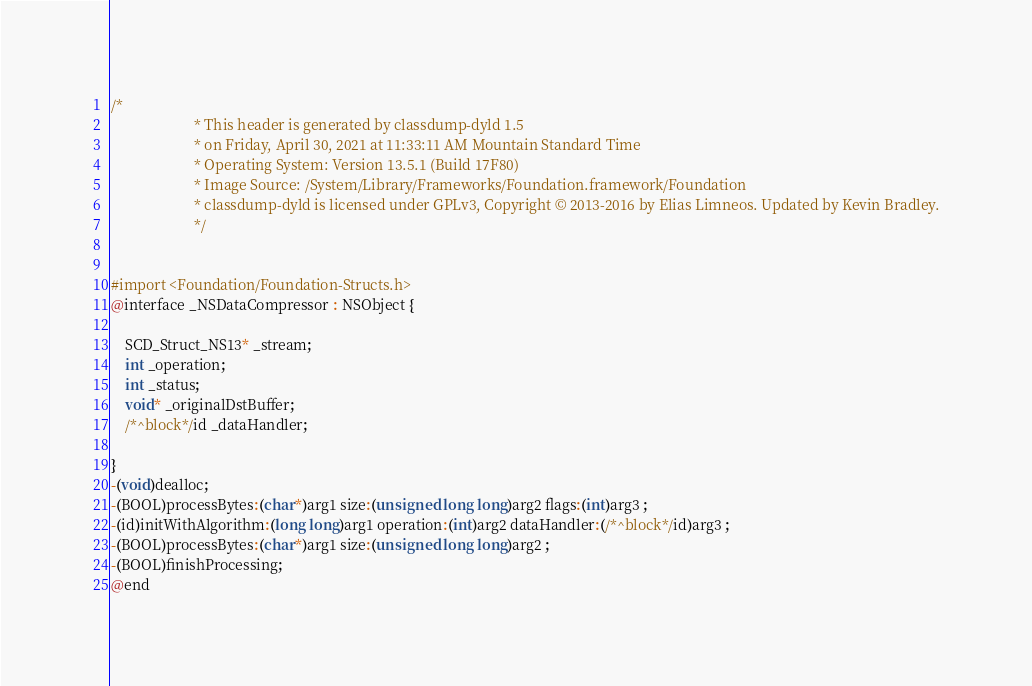Convert code to text. <code><loc_0><loc_0><loc_500><loc_500><_C_>/*
                       * This header is generated by classdump-dyld 1.5
                       * on Friday, April 30, 2021 at 11:33:11 AM Mountain Standard Time
                       * Operating System: Version 13.5.1 (Build 17F80)
                       * Image Source: /System/Library/Frameworks/Foundation.framework/Foundation
                       * classdump-dyld is licensed under GPLv3, Copyright © 2013-2016 by Elias Limneos. Updated by Kevin Bradley.
                       */


#import <Foundation/Foundation-Structs.h>
@interface _NSDataCompressor : NSObject {

	SCD_Struct_NS13* _stream;
	int _operation;
	int _status;
	void* _originalDstBuffer;
	/*^block*/id _dataHandler;

}
-(void)dealloc;
-(BOOL)processBytes:(char*)arg1 size:(unsigned long long)arg2 flags:(int)arg3 ;
-(id)initWithAlgorithm:(long long)arg1 operation:(int)arg2 dataHandler:(/*^block*/id)arg3 ;
-(BOOL)processBytes:(char*)arg1 size:(unsigned long long)arg2 ;
-(BOOL)finishProcessing;
@end

</code> 